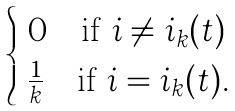Convert formula to latex. <formula><loc_0><loc_0><loc_500><loc_500>\begin{cases} \ 0 \quad \text {if} \ i \neq i _ { k } ( t ) \\ \ \frac { 1 } { k } \quad \text {if} \ i = i _ { k } ( t ) . \end{cases}</formula> 